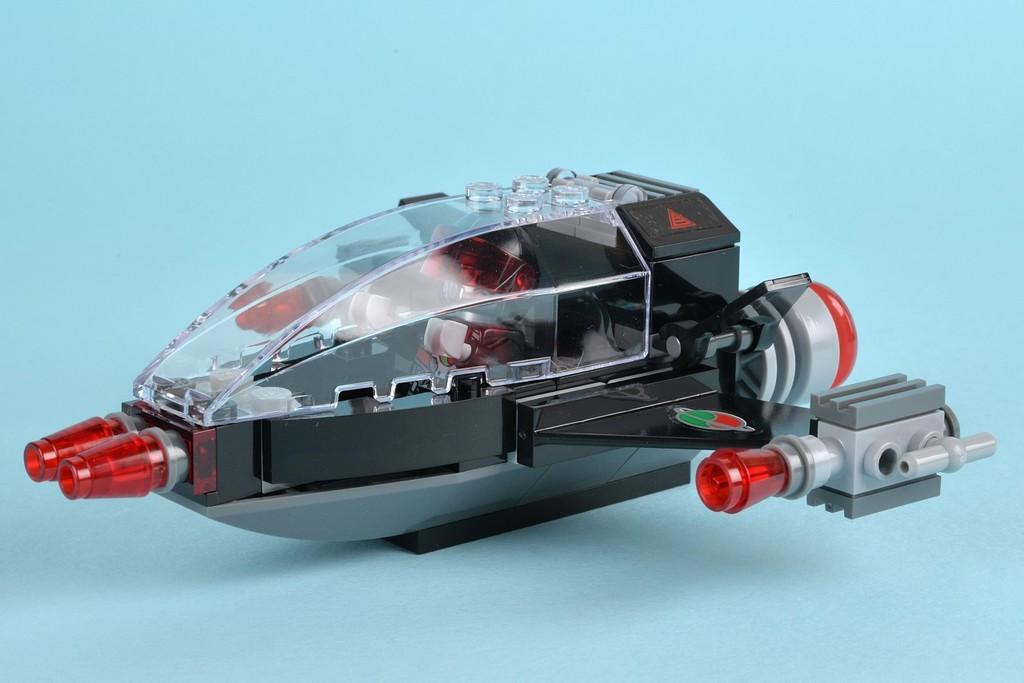What is the main object in the image? There is an object that seems to be a toy in the image. What is the toy placed on? The toy is placed on a blue object. What type of distribution system is visible in the image? There is no distribution system present in the image. Is there a bomb visible in the image? No, there is no bomb visible in the image. 